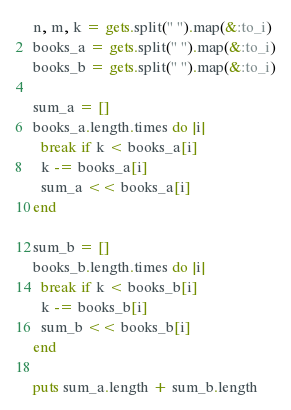<code> <loc_0><loc_0><loc_500><loc_500><_Ruby_>n, m, k = gets.split(" ").map(&:to_i)
books_a = gets.split(" ").map(&:to_i)
books_b = gets.split(" ").map(&:to_i)

sum_a = []
books_a.length.times do |i|
  break if k < books_a[i]
  k -= books_a[i]
  sum_a << books_a[i]
end

sum_b = []
books_b.length.times do |i|
  break if k < books_b[i]
  k -= books_b[i]
  sum_b << books_b[i]
end

puts sum_a.length + sum_b.length</code> 